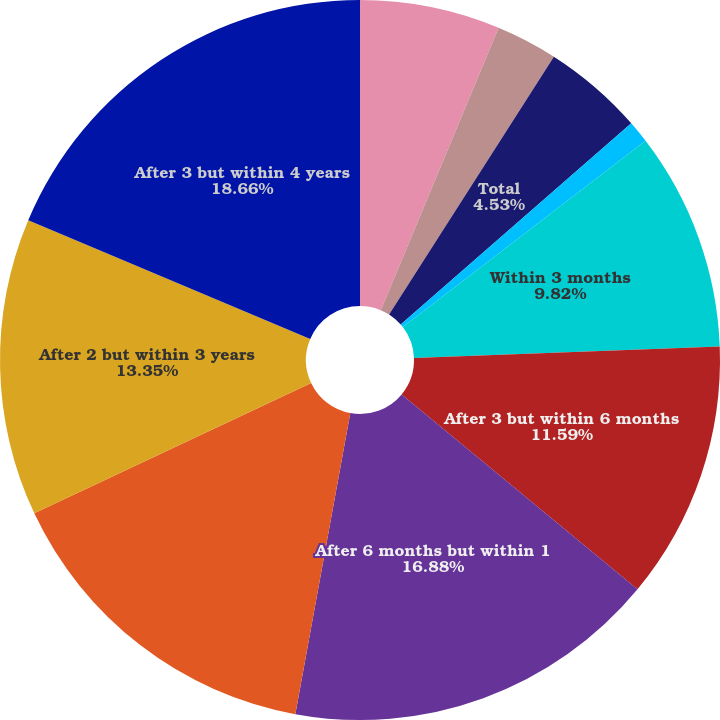Convert chart to OTSL. <chart><loc_0><loc_0><loc_500><loc_500><pie_chart><fcel>Money market<fcel>Interest-bearing checking<fcel>Total<fcel>Savings<fcel>Within 3 months<fcel>After 3 but within 6 months<fcel>After 6 months but within 1<fcel>After 1 but within 2 years<fcel>After 2 but within 3 years<fcel>After 3 but within 4 years<nl><fcel>6.29%<fcel>2.76%<fcel>4.53%<fcel>1.0%<fcel>9.82%<fcel>11.59%<fcel>16.88%<fcel>15.12%<fcel>13.35%<fcel>18.65%<nl></chart> 